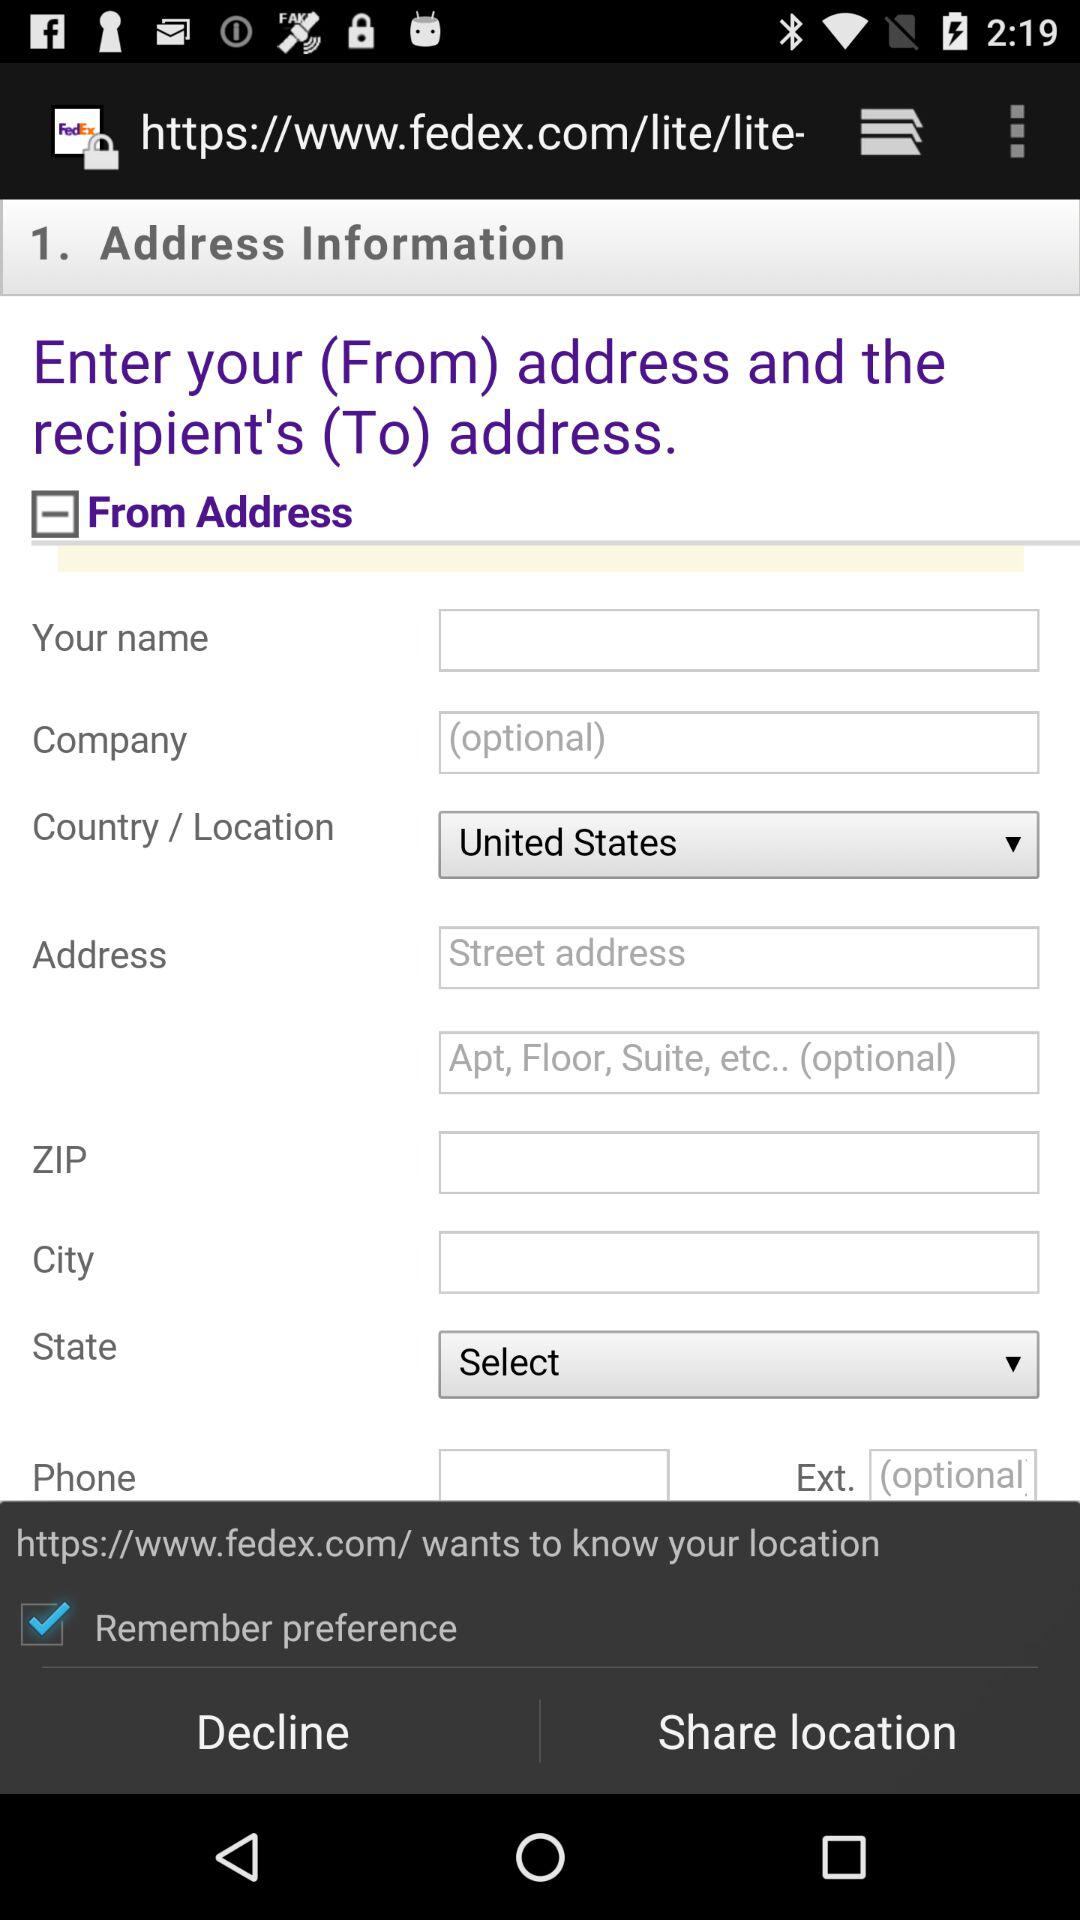What is the status of "Remember preference"? The status is "on". 